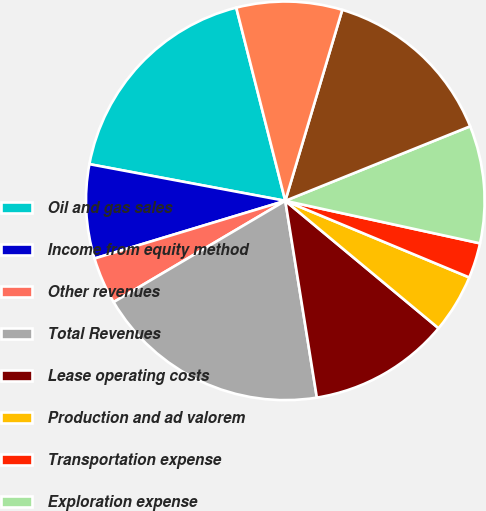Convert chart to OTSL. <chart><loc_0><loc_0><loc_500><loc_500><pie_chart><fcel>Oil and gas sales<fcel>Income from equity method<fcel>Other revenues<fcel>Total Revenues<fcel>Lease operating costs<fcel>Production and ad valorem<fcel>Transportation expense<fcel>Exploration expense<fcel>Depreciation depletion and<fcel>General and administrative<nl><fcel>18.1%<fcel>7.62%<fcel>3.81%<fcel>19.05%<fcel>11.43%<fcel>4.76%<fcel>2.86%<fcel>9.52%<fcel>14.29%<fcel>8.57%<nl></chart> 